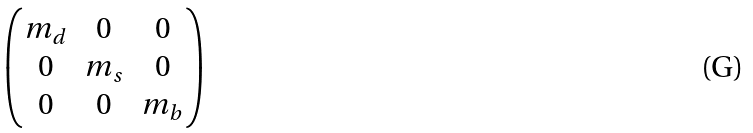<formula> <loc_0><loc_0><loc_500><loc_500>\begin{pmatrix} m _ { d } & 0 & 0 \\ 0 & m _ { s } & 0 \\ 0 & 0 & m _ { b } \end{pmatrix}</formula> 